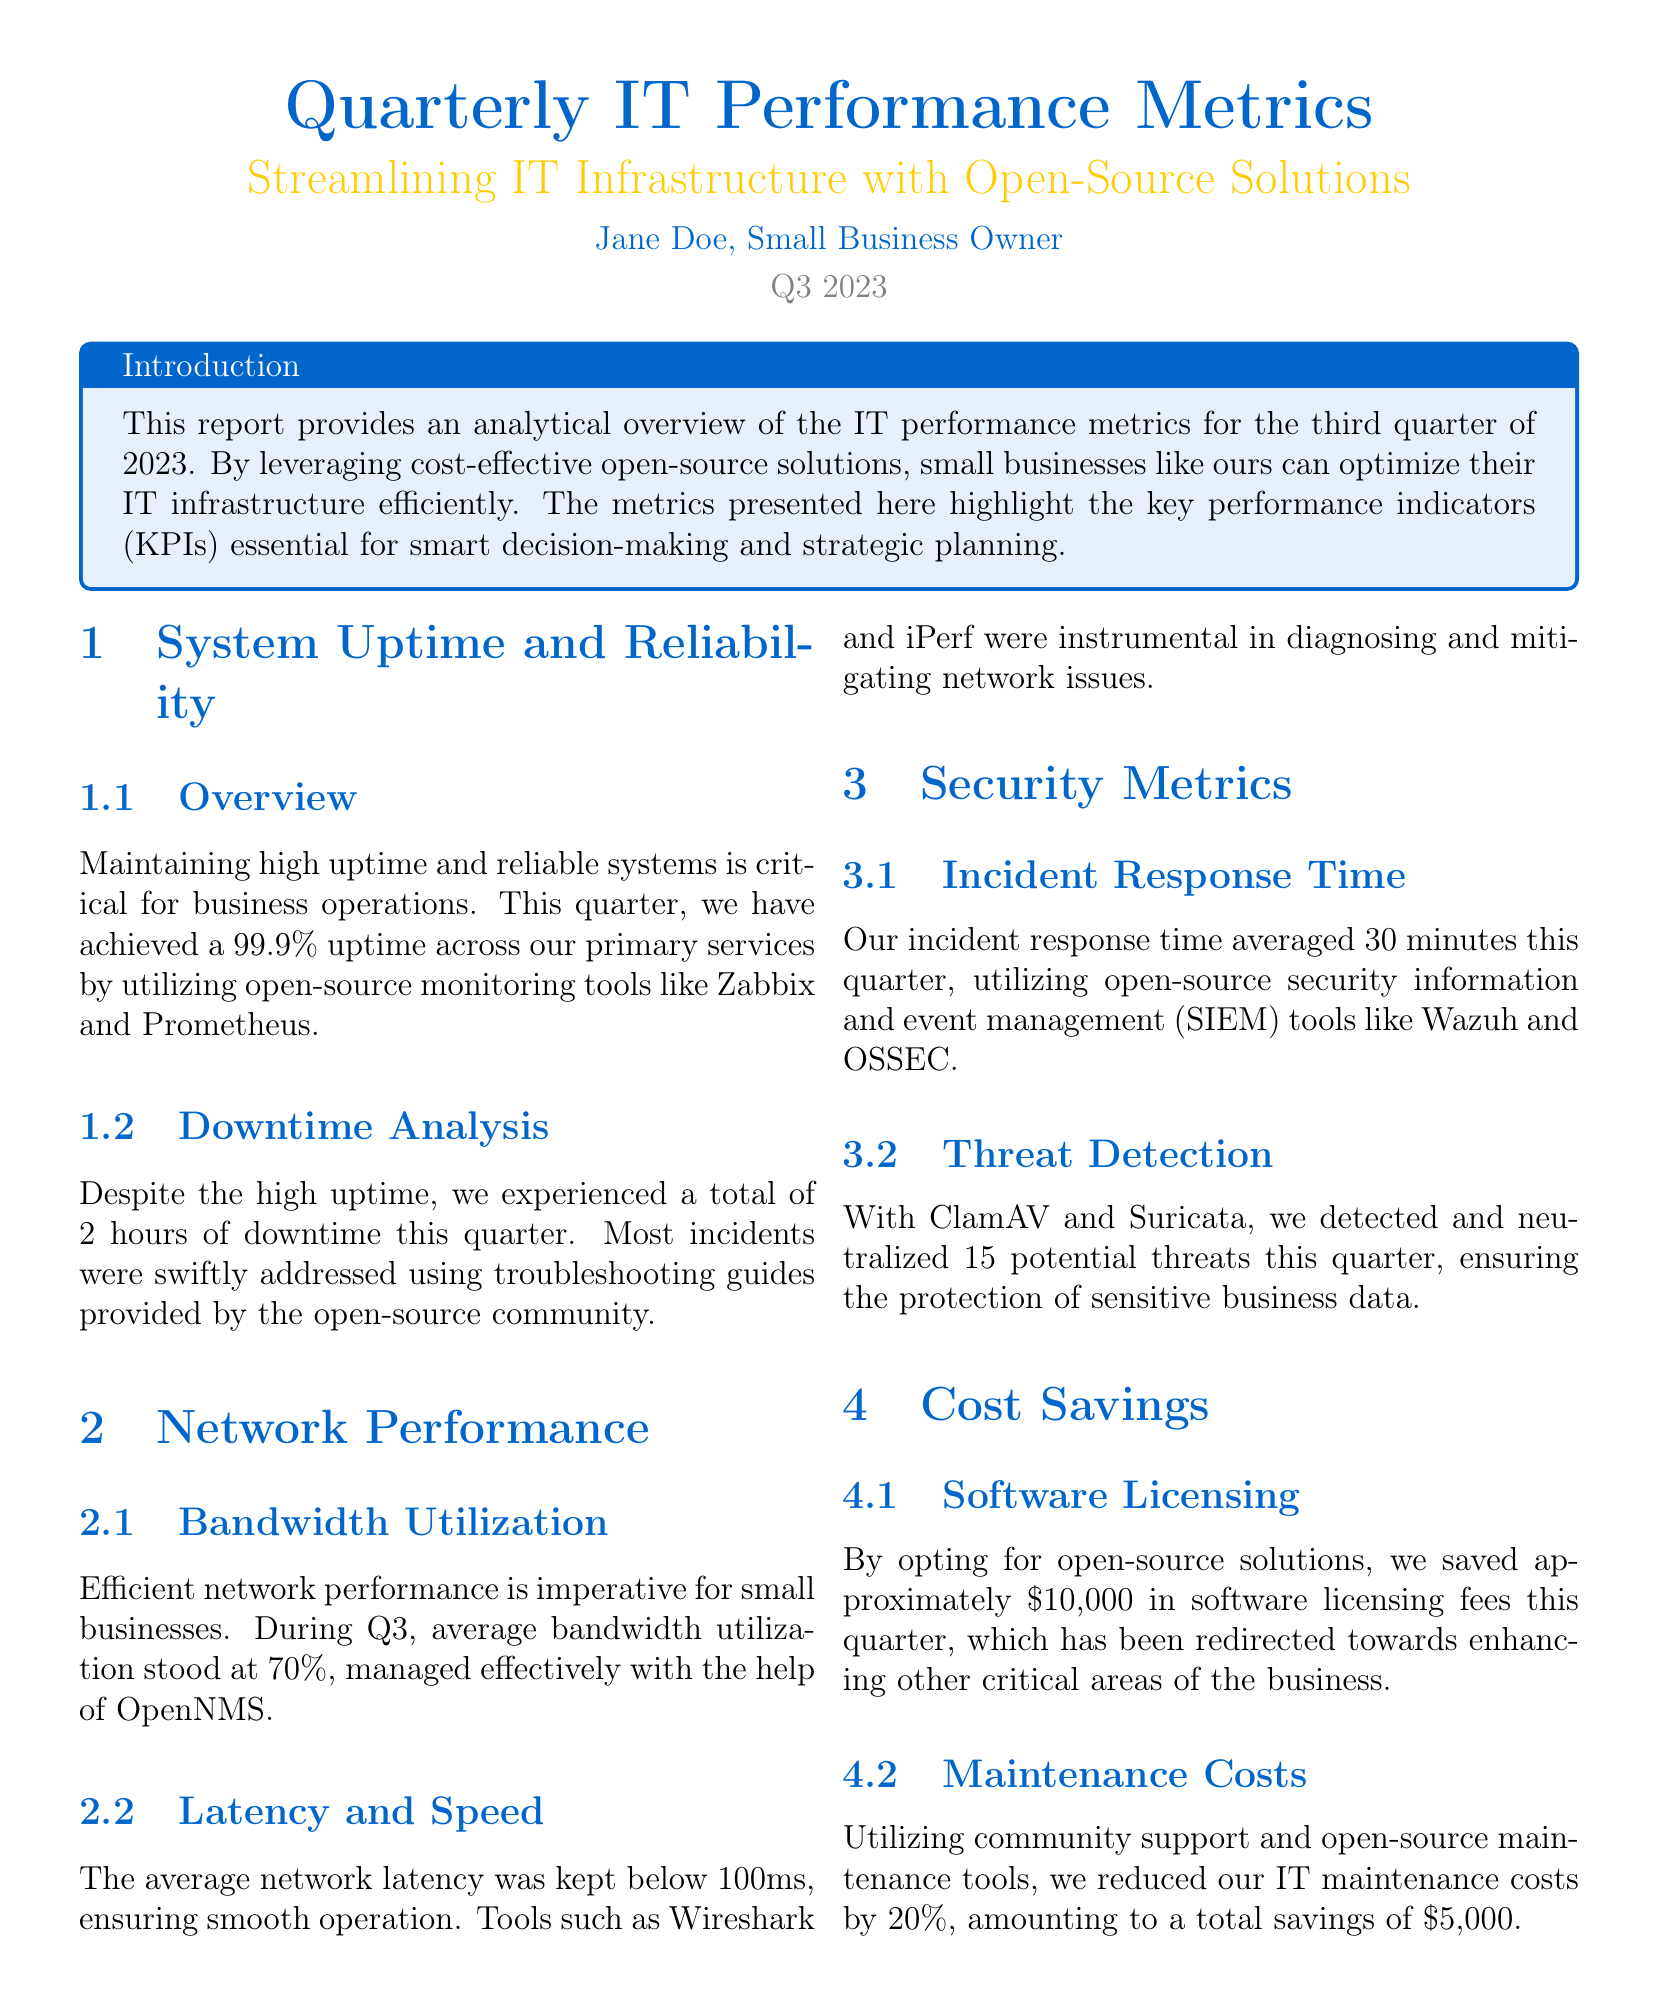What is the uptime percentage achieved this quarter? The uptime percentage achieved this quarter is stated in the document as 99.9%.
Answer: 99.9% How many hours of downtime were experienced? The document mentions that a total of 2 hours of downtime was experienced during the quarter.
Answer: 2 hours What tools were used for monitoring in the report? The tools used for monitoring include Zabbix and Prometheus, as specified in the document.
Answer: Zabbix and Prometheus What was the average incident response time for security? The average incident response time, according to the document, was 30 minutes.
Answer: 30 minutes What was the total cost savings from software licensing? The document states that approximately 10,000 dollars were saved from software licensing fees.
Answer: $10,000 How much were maintenance costs reduced by? The document indicates that IT maintenance costs were reduced by 20%.
Answer: 20% What open-source tools were used to maintain network performance? The tools mentioned for managing network performance include OpenNMS, Wireshark, and iPerf.
Answer: OpenNMS, Wireshark, iPerf Which metric indicates performance optimization for the next quarter? The document implies that continuous monitoring serves as a metric for performance optimization in the next quarter.
Answer: Continuous monitoring 